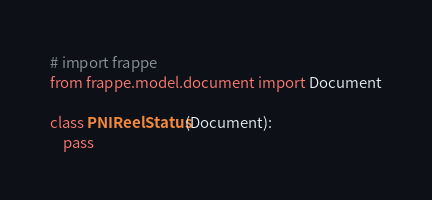Convert code to text. <code><loc_0><loc_0><loc_500><loc_500><_Python_># import frappe
from frappe.model.document import Document

class PNIReelStatus(Document):
	pass
</code> 